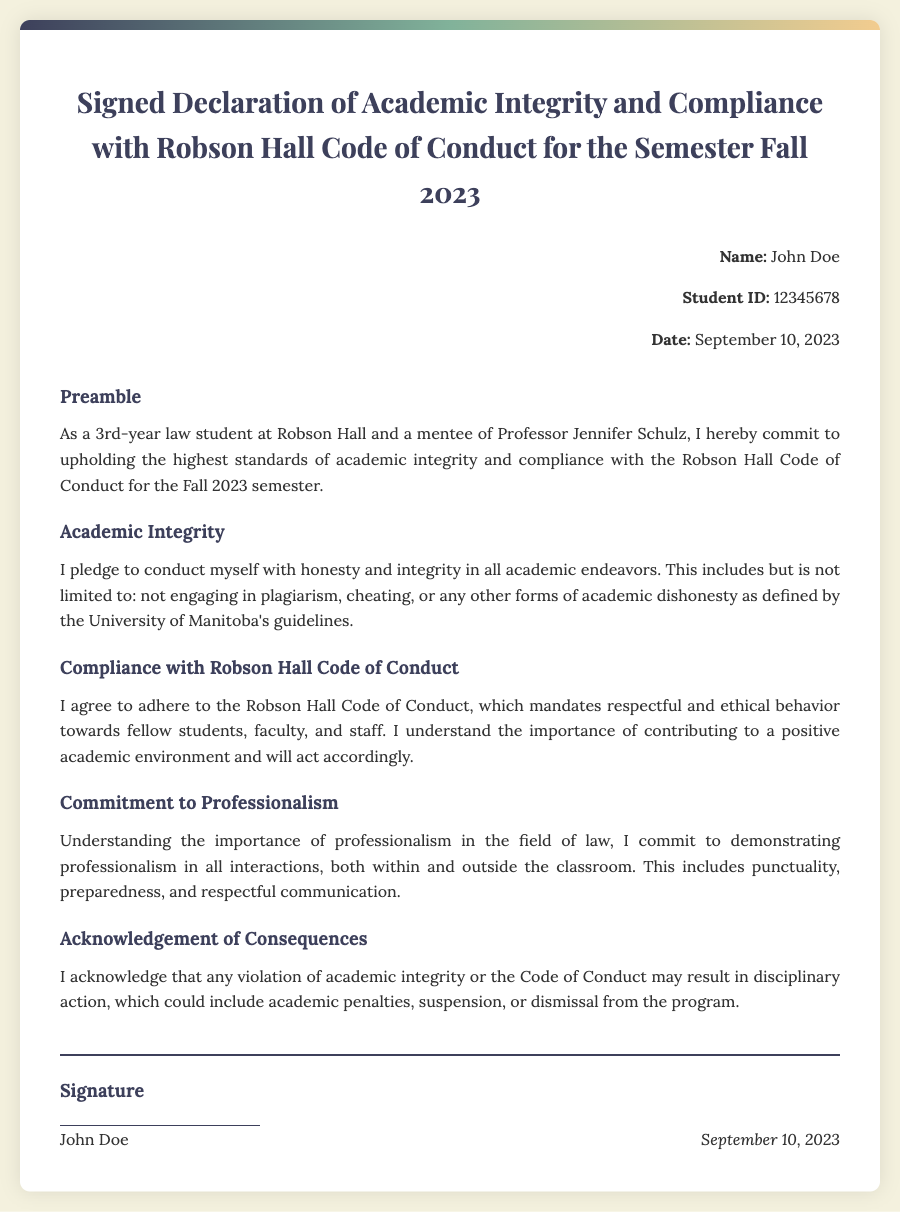What is the title of the document? The title is found at the top of the document, summarizing its content.
Answer: Signed Declaration of Academic Integrity and Compliance with Robson Hall Code of Conduct for the Semester Fall 2023 Who is the student named in the document? The student's name is located in the student information section.
Answer: John Doe What is the student ID number? The student ID is provided in the student information section.
Answer: 12345678 What date is the declaration signed? The date is mentioned at the end of the document, indicating when it was signed.
Answer: September 10, 2023 What commitment is made regarding academic integrity? This is described in the Academic Integrity section of the document.
Answer: Conduct myself with honesty and integrity What does the student agree to adhere to? This information is found in the Compliance with Robson Hall Code of Conduct section.
Answer: Robson Hall Code of Conduct What is acknowledged in the Acknowledgement of Consequences section? The document explains the implications of violating the standards set forth.
Answer: Disciplinary action What is the importance of professionalism mentioned in the document? This is detailed in the Commitment to Professionalism section.
Answer: Importance of professionalism in the field of law What is the signature of the student? The document includes a personal signature area indicating the student's agreement.
Answer: John Doe 